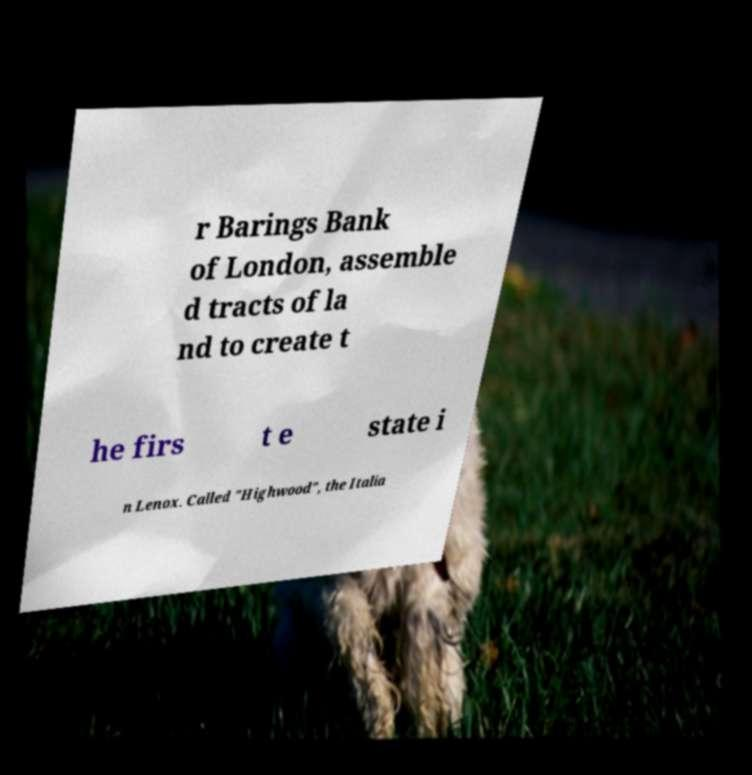Please identify and transcribe the text found in this image. r Barings Bank of London, assemble d tracts of la nd to create t he firs t e state i n Lenox. Called "Highwood", the Italia 